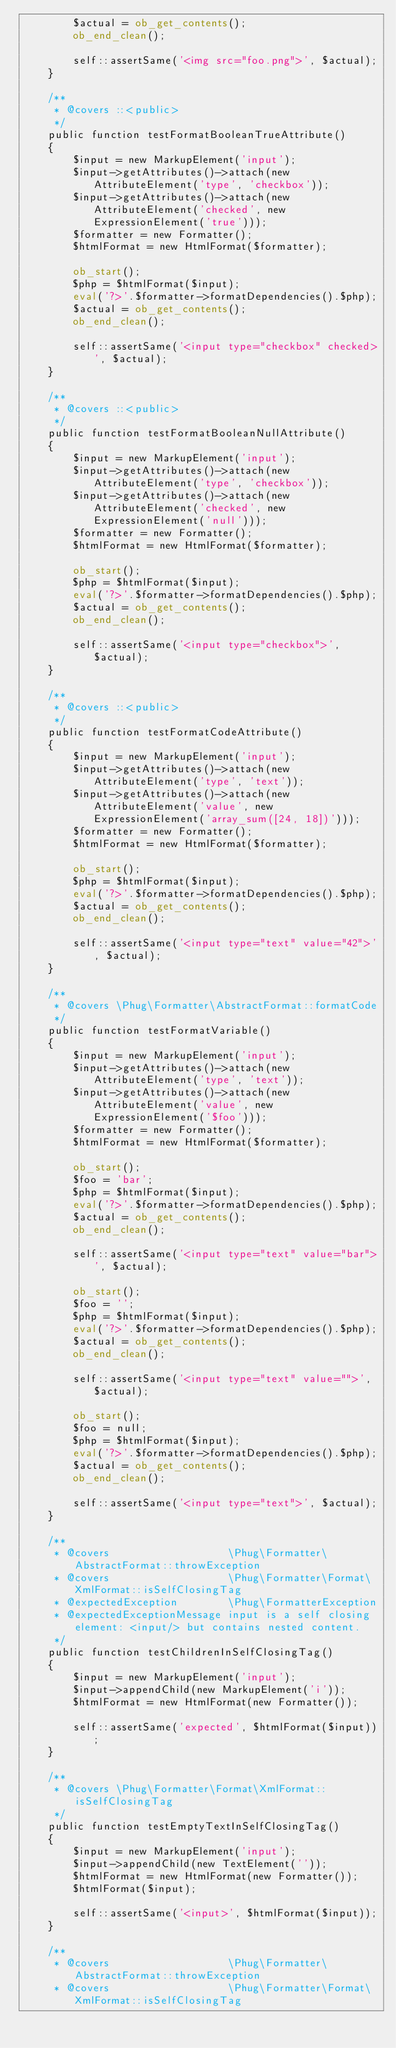<code> <loc_0><loc_0><loc_500><loc_500><_PHP_>        $actual = ob_get_contents();
        ob_end_clean();

        self::assertSame('<img src="foo.png">', $actual);
    }

    /**
     * @covers ::<public>
     */
    public function testFormatBooleanTrueAttribute()
    {
        $input = new MarkupElement('input');
        $input->getAttributes()->attach(new AttributeElement('type', 'checkbox'));
        $input->getAttributes()->attach(new AttributeElement('checked', new ExpressionElement('true')));
        $formatter = new Formatter();
        $htmlFormat = new HtmlFormat($formatter);

        ob_start();
        $php = $htmlFormat($input);
        eval('?>'.$formatter->formatDependencies().$php);
        $actual = ob_get_contents();
        ob_end_clean();

        self::assertSame('<input type="checkbox" checked>', $actual);
    }

    /**
     * @covers ::<public>
     */
    public function testFormatBooleanNullAttribute()
    {
        $input = new MarkupElement('input');
        $input->getAttributes()->attach(new AttributeElement('type', 'checkbox'));
        $input->getAttributes()->attach(new AttributeElement('checked', new ExpressionElement('null')));
        $formatter = new Formatter();
        $htmlFormat = new HtmlFormat($formatter);

        ob_start();
        $php = $htmlFormat($input);
        eval('?>'.$formatter->formatDependencies().$php);
        $actual = ob_get_contents();
        ob_end_clean();

        self::assertSame('<input type="checkbox">', $actual);
    }

    /**
     * @covers ::<public>
     */
    public function testFormatCodeAttribute()
    {
        $input = new MarkupElement('input');
        $input->getAttributes()->attach(new AttributeElement('type', 'text'));
        $input->getAttributes()->attach(new AttributeElement('value', new ExpressionElement('array_sum([24, 18])')));
        $formatter = new Formatter();
        $htmlFormat = new HtmlFormat($formatter);

        ob_start();
        $php = $htmlFormat($input);
        eval('?>'.$formatter->formatDependencies().$php);
        $actual = ob_get_contents();
        ob_end_clean();

        self::assertSame('<input type="text" value="42">', $actual);
    }

    /**
     * @covers \Phug\Formatter\AbstractFormat::formatCode
     */
    public function testFormatVariable()
    {
        $input = new MarkupElement('input');
        $input->getAttributes()->attach(new AttributeElement('type', 'text'));
        $input->getAttributes()->attach(new AttributeElement('value', new ExpressionElement('$foo')));
        $formatter = new Formatter();
        $htmlFormat = new HtmlFormat($formatter);

        ob_start();
        $foo = 'bar';
        $php = $htmlFormat($input);
        eval('?>'.$formatter->formatDependencies().$php);
        $actual = ob_get_contents();
        ob_end_clean();

        self::assertSame('<input type="text" value="bar">', $actual);

        ob_start();
        $foo = '';
        $php = $htmlFormat($input);
        eval('?>'.$formatter->formatDependencies().$php);
        $actual = ob_get_contents();
        ob_end_clean();

        self::assertSame('<input type="text" value="">', $actual);

        ob_start();
        $foo = null;
        $php = $htmlFormat($input);
        eval('?>'.$formatter->formatDependencies().$php);
        $actual = ob_get_contents();
        ob_end_clean();

        self::assertSame('<input type="text">', $actual);
    }

    /**
     * @covers                   \Phug\Formatter\AbstractFormat::throwException
     * @covers                   \Phug\Formatter\Format\XmlFormat::isSelfClosingTag
     * @expectedException        \Phug\FormatterException
     * @expectedExceptionMessage input is a self closing element: <input/> but contains nested content.
     */
    public function testChildrenInSelfClosingTag()
    {
        $input = new MarkupElement('input');
        $input->appendChild(new MarkupElement('i'));
        $htmlFormat = new HtmlFormat(new Formatter());

        self::assertSame('expected', $htmlFormat($input));
    }

    /**
     * @covers \Phug\Formatter\Format\XmlFormat::isSelfClosingTag
     */
    public function testEmptyTextInSelfClosingTag()
    {
        $input = new MarkupElement('input');
        $input->appendChild(new TextElement(''));
        $htmlFormat = new HtmlFormat(new Formatter());
        $htmlFormat($input);

        self::assertSame('<input>', $htmlFormat($input));
    }

    /**
     * @covers                   \Phug\Formatter\AbstractFormat::throwException
     * @covers                   \Phug\Formatter\Format\XmlFormat::isSelfClosingTag</code> 